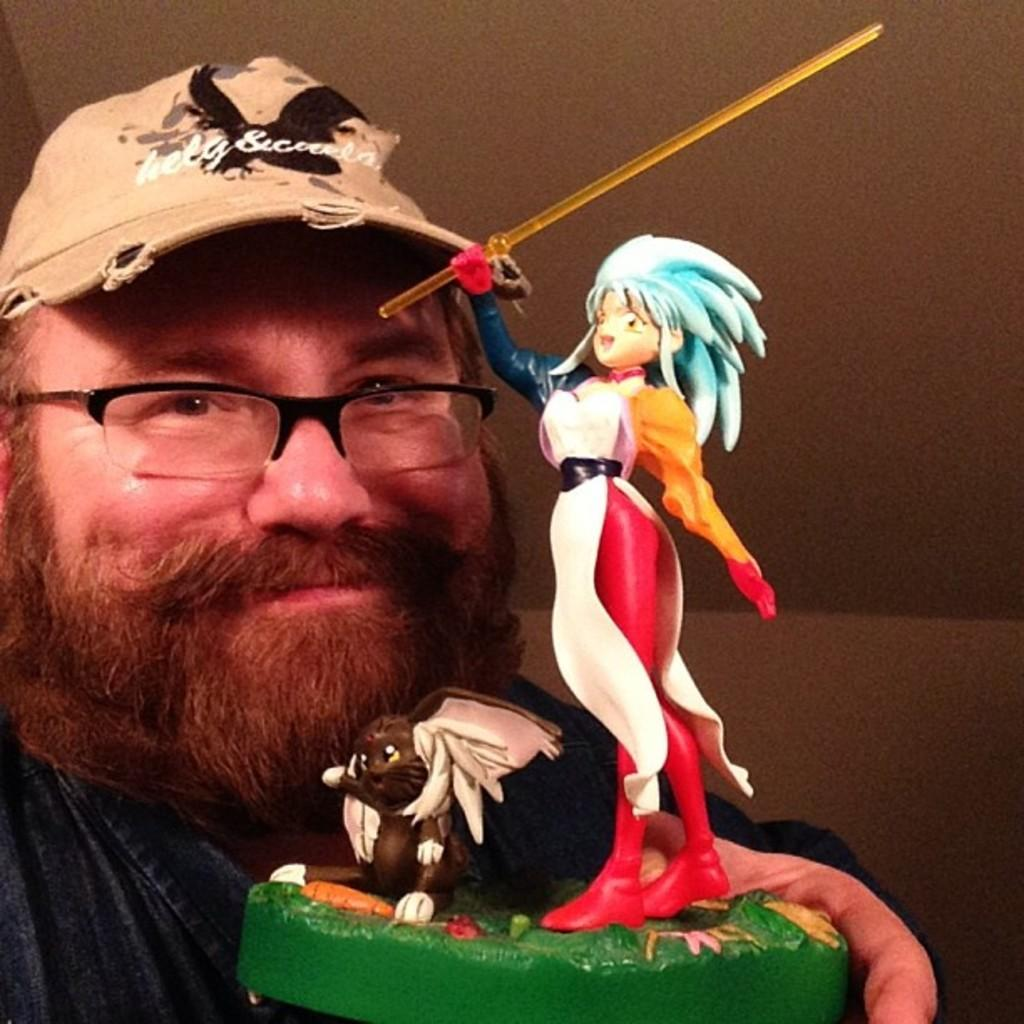What is the main subject of the image? The main subject of the image is a man. What is the man holding in the image? The man is holding a toy in the image. What type of headwear is the man wearing? The man is wearing a cap in the image. What type of eyewear is the man wearing? The man is wearing spectacles in the image. Can you tell me how many boats are docked at the harbor in the image? There is no harbor or boats present in the image; it features a man holding a toy and wearing a cap and spectacles. What type of crime is being committed in the image? There is no crime being committed in the image; it features a man holding a toy and wearing a cap and spectacles. 